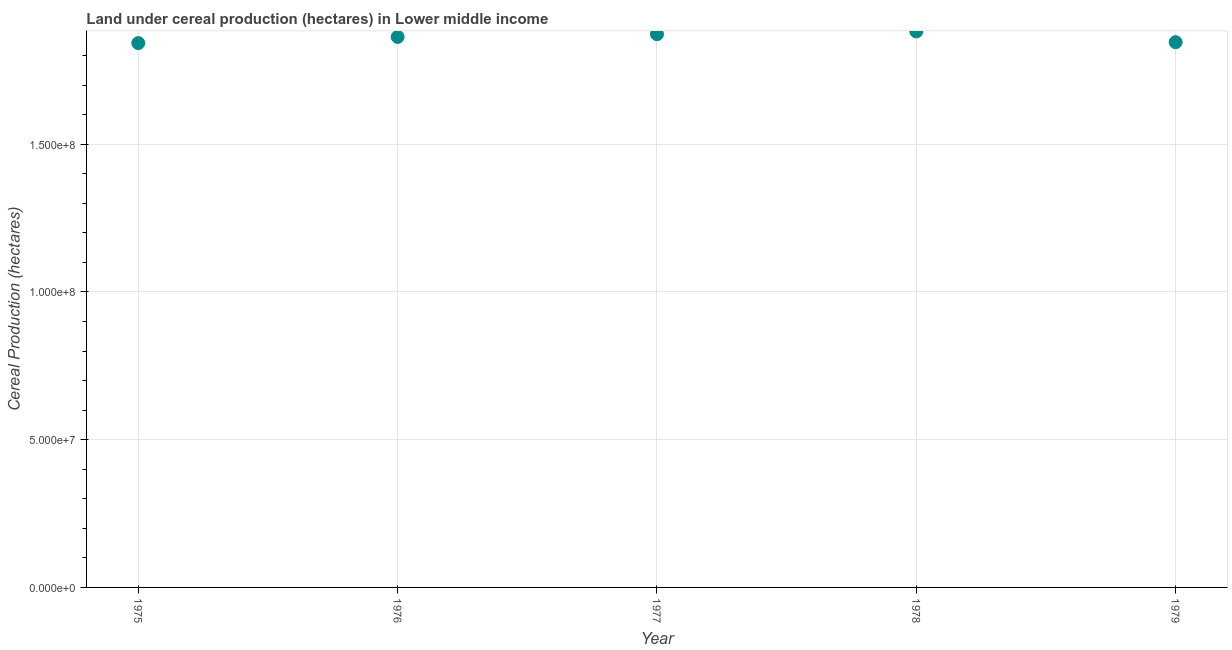What is the land under cereal production in 1976?
Your answer should be compact. 1.86e+08. Across all years, what is the maximum land under cereal production?
Offer a terse response. 1.88e+08. Across all years, what is the minimum land under cereal production?
Make the answer very short. 1.84e+08. In which year was the land under cereal production maximum?
Provide a short and direct response. 1978. In which year was the land under cereal production minimum?
Keep it short and to the point. 1975. What is the sum of the land under cereal production?
Provide a succinct answer. 9.30e+08. What is the difference between the land under cereal production in 1975 and 1979?
Keep it short and to the point. -3.13e+05. What is the average land under cereal production per year?
Your answer should be very brief. 1.86e+08. What is the median land under cereal production?
Give a very brief answer. 1.86e+08. Do a majority of the years between 1979 and 1976 (inclusive) have land under cereal production greater than 170000000 hectares?
Provide a short and direct response. Yes. What is the ratio of the land under cereal production in 1977 to that in 1979?
Offer a terse response. 1.01. What is the difference between the highest and the second highest land under cereal production?
Keep it short and to the point. 9.38e+05. Is the sum of the land under cereal production in 1975 and 1979 greater than the maximum land under cereal production across all years?
Provide a short and direct response. Yes. What is the difference between the highest and the lowest land under cereal production?
Your response must be concise. 3.96e+06. How many dotlines are there?
Make the answer very short. 1. What is the difference between two consecutive major ticks on the Y-axis?
Make the answer very short. 5.00e+07. Are the values on the major ticks of Y-axis written in scientific E-notation?
Ensure brevity in your answer.  Yes. Does the graph contain any zero values?
Offer a terse response. No. Does the graph contain grids?
Your answer should be very brief. Yes. What is the title of the graph?
Provide a short and direct response. Land under cereal production (hectares) in Lower middle income. What is the label or title of the X-axis?
Ensure brevity in your answer.  Year. What is the label or title of the Y-axis?
Your response must be concise. Cereal Production (hectares). What is the Cereal Production (hectares) in 1975?
Offer a very short reply. 1.84e+08. What is the Cereal Production (hectares) in 1976?
Make the answer very short. 1.86e+08. What is the Cereal Production (hectares) in 1977?
Keep it short and to the point. 1.87e+08. What is the Cereal Production (hectares) in 1978?
Keep it short and to the point. 1.88e+08. What is the Cereal Production (hectares) in 1979?
Provide a succinct answer. 1.85e+08. What is the difference between the Cereal Production (hectares) in 1975 and 1976?
Keep it short and to the point. -2.09e+06. What is the difference between the Cereal Production (hectares) in 1975 and 1977?
Your response must be concise. -3.02e+06. What is the difference between the Cereal Production (hectares) in 1975 and 1978?
Keep it short and to the point. -3.96e+06. What is the difference between the Cereal Production (hectares) in 1975 and 1979?
Offer a very short reply. -3.13e+05. What is the difference between the Cereal Production (hectares) in 1976 and 1977?
Provide a short and direct response. -9.28e+05. What is the difference between the Cereal Production (hectares) in 1976 and 1978?
Make the answer very short. -1.87e+06. What is the difference between the Cereal Production (hectares) in 1976 and 1979?
Provide a short and direct response. 1.78e+06. What is the difference between the Cereal Production (hectares) in 1977 and 1978?
Offer a terse response. -9.38e+05. What is the difference between the Cereal Production (hectares) in 1977 and 1979?
Your response must be concise. 2.71e+06. What is the difference between the Cereal Production (hectares) in 1978 and 1979?
Offer a very short reply. 3.64e+06. What is the ratio of the Cereal Production (hectares) in 1975 to that in 1976?
Keep it short and to the point. 0.99. What is the ratio of the Cereal Production (hectares) in 1975 to that in 1978?
Your answer should be compact. 0.98. What is the ratio of the Cereal Production (hectares) in 1975 to that in 1979?
Make the answer very short. 1. What is the ratio of the Cereal Production (hectares) in 1976 to that in 1978?
Ensure brevity in your answer.  0.99. What is the ratio of the Cereal Production (hectares) in 1976 to that in 1979?
Give a very brief answer. 1.01. What is the ratio of the Cereal Production (hectares) in 1977 to that in 1978?
Give a very brief answer. 0.99. 